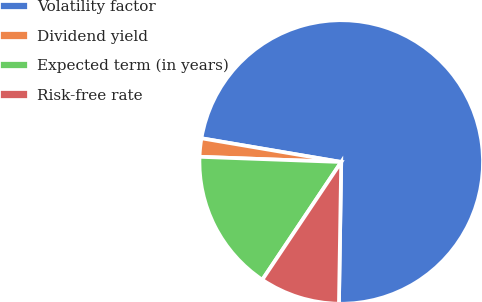Convert chart to OTSL. <chart><loc_0><loc_0><loc_500><loc_500><pie_chart><fcel>Volatility factor<fcel>Dividend yield<fcel>Expected term (in years)<fcel>Risk-free rate<nl><fcel>72.59%<fcel>2.09%<fcel>16.19%<fcel>9.14%<nl></chart> 